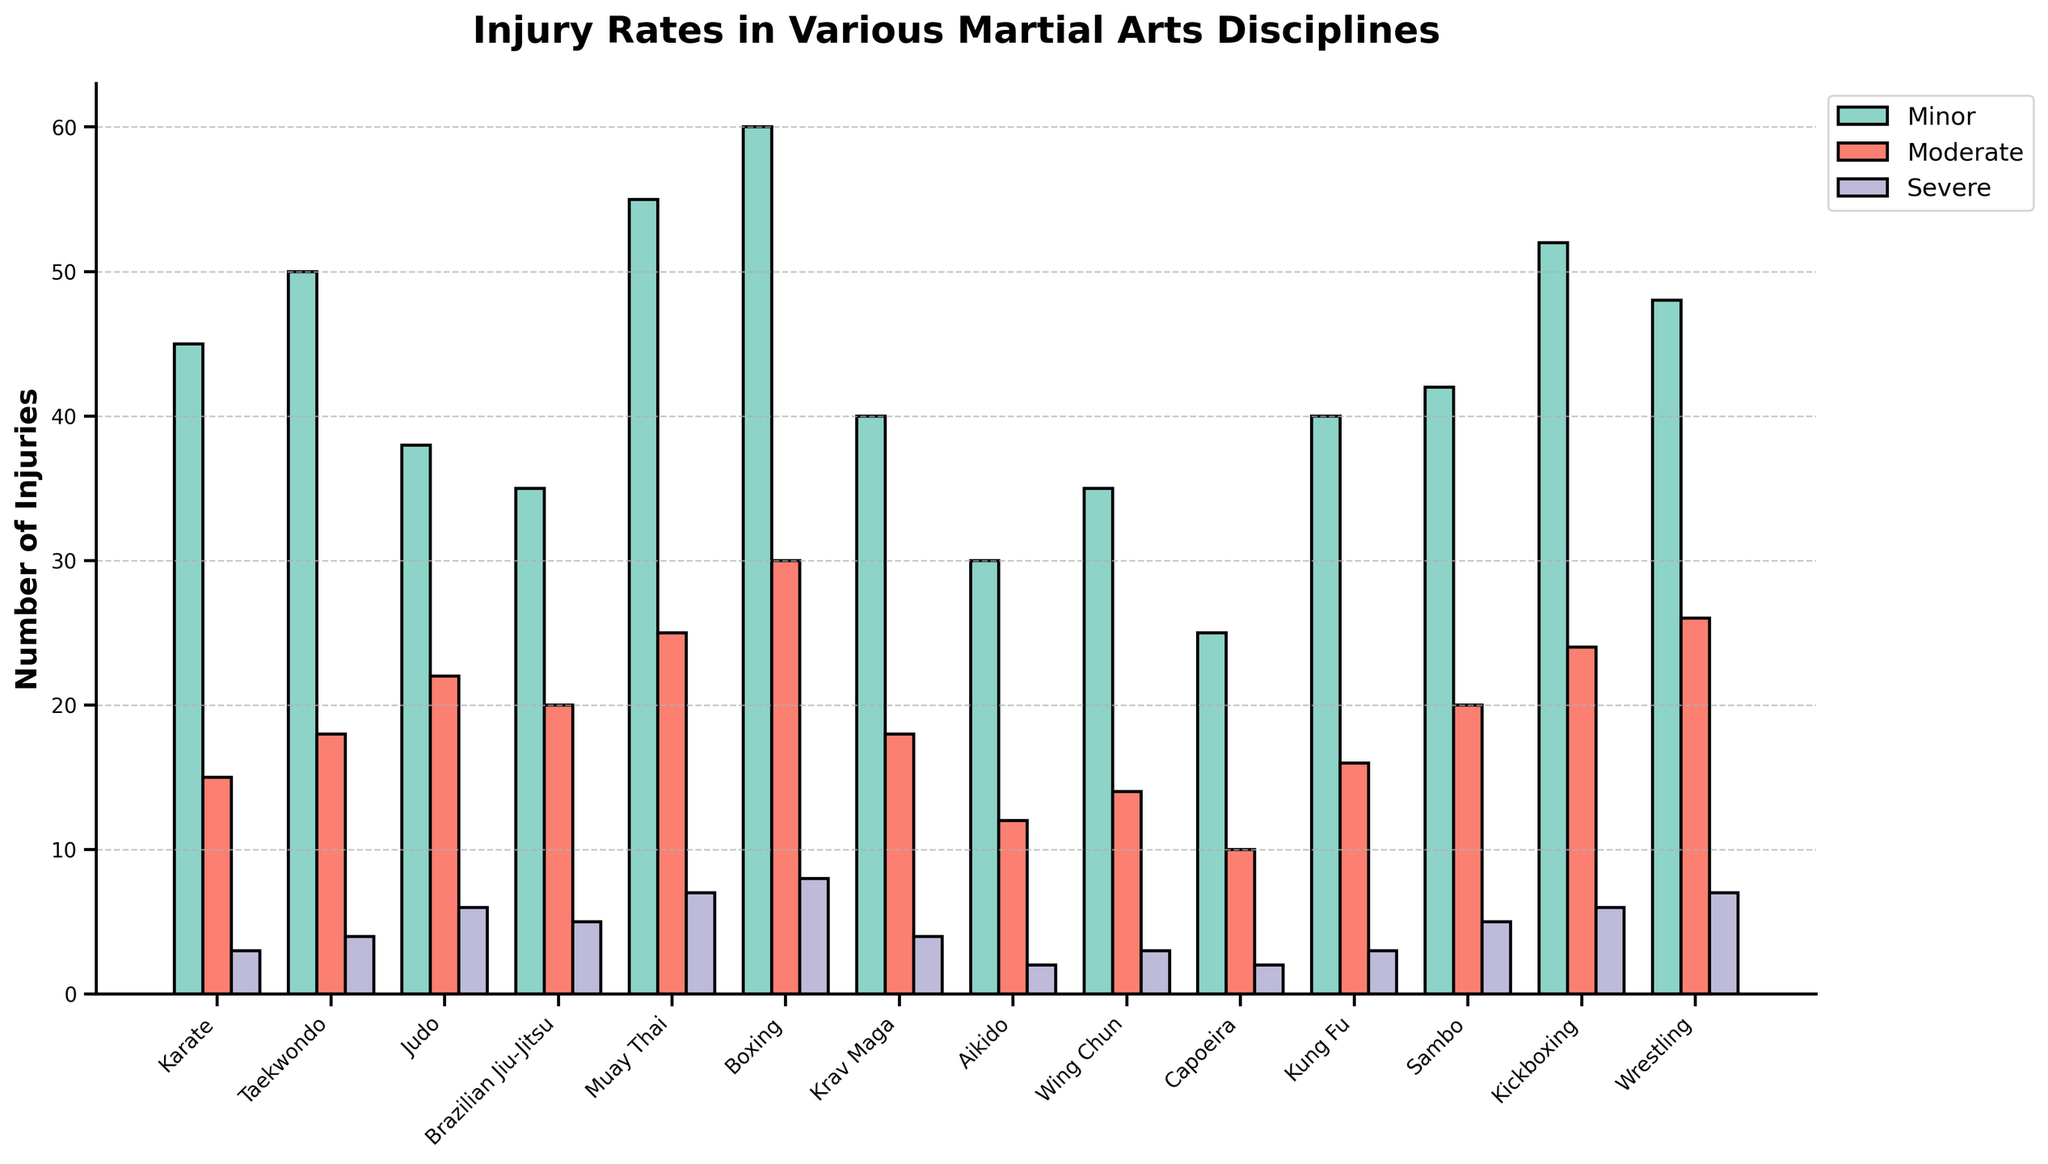Which martial art has the highest number of minor injuries? By examining the heights of the green bars representing minor injuries, we can see that Boxing has the tallest bar in this category.
Answer: Boxing Which two martial arts have an equal number of severe injuries? By comparing the purple bars representing severe injuries, we see that Karate and Wing Chun both have bars at the same height level for severe injuries, specifically at 3 injuries each.
Answer: Karate and Wing Chun Which martial art has the lowest total number of injuries across all categories? To determine this, we add the heights of all the bars (minor, moderate, severe) for each martial art and compare the totals. Capoeira has the shortest cumulative bar heights: 25 (minor) + 10 (moderate) + 2 (severe) = 37.
Answer: Capoeira Is the number of moderate injuries in Judo greater than in Karate? By comparing the heights of the red bars for moderate injuries, Judo has 22 while Karate has 15. Therefore, Judo has more moderate injuries than Karate.
Answer: Yes What is the difference in the number of severe injuries between Muay Thai and Aikido? By examining the purple bars, Muay Thai has 7 severe injuries while Aikido has 2. The difference is 7 - 2 = 5.
Answer: 5 How many more total injuries does Boxing have compared to Aikido? To compute this, we sum the injuries for each martial art. Boxing has 60 (minor) + 30 (moderate) + 8 (severe) = 98, and Aikido has 30 (minor) + 12 (moderate) + 2 (severe) = 44. The difference is 98 - 44 = 54.
Answer: 54 Which martial art has exactly half the number of minor injuries compared to Boxing? Boxing has 60 minor injuries. Half of that is 30. Checking the green bars, Aikido has 30 minor injuries.
Answer: Aikido What is the total number of severe injuries recorded for all martial arts combined? By summing the heights of all the purple bars: 3 (Karate) + 4 (Taekwondo) + 6 (Judo) + 5 (Brazilian Jiu-Jitsu) + 7 (Muay Thai) + 8 (Boxing) + 4 (Krav Maga) + 2 (Aikido) + 3 (Wing Chun) + 2 (Capoeira) + 3 (Kung Fu) + 5 (Sambo) + 6 (Kickboxing) + 7 (Wrestling), the total is 65.
Answer: 65 